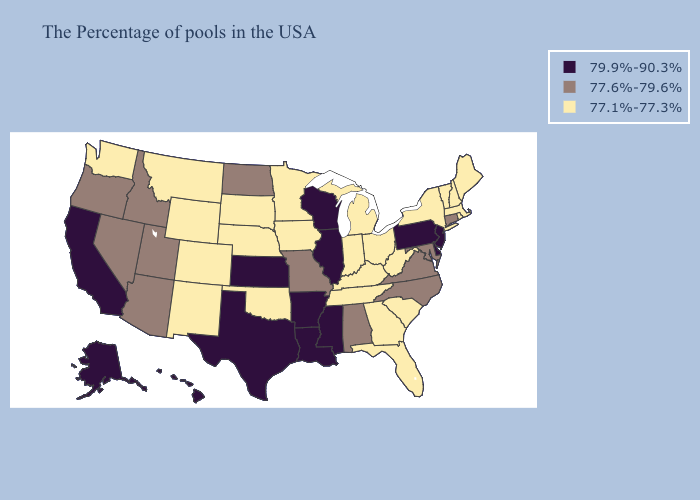Does Florida have the lowest value in the South?
Short answer required. Yes. Name the states that have a value in the range 77.6%-79.6%?
Give a very brief answer. Connecticut, Maryland, Virginia, North Carolina, Alabama, Missouri, North Dakota, Utah, Arizona, Idaho, Nevada, Oregon. What is the value of South Dakota?
Short answer required. 77.1%-77.3%. Name the states that have a value in the range 77.1%-77.3%?
Keep it brief. Maine, Massachusetts, Rhode Island, New Hampshire, Vermont, New York, South Carolina, West Virginia, Ohio, Florida, Georgia, Michigan, Kentucky, Indiana, Tennessee, Minnesota, Iowa, Nebraska, Oklahoma, South Dakota, Wyoming, Colorado, New Mexico, Montana, Washington. What is the value of Mississippi?
Give a very brief answer. 79.9%-90.3%. Name the states that have a value in the range 77.1%-77.3%?
Be succinct. Maine, Massachusetts, Rhode Island, New Hampshire, Vermont, New York, South Carolina, West Virginia, Ohio, Florida, Georgia, Michigan, Kentucky, Indiana, Tennessee, Minnesota, Iowa, Nebraska, Oklahoma, South Dakota, Wyoming, Colorado, New Mexico, Montana, Washington. Does the first symbol in the legend represent the smallest category?
Write a very short answer. No. Does the map have missing data?
Write a very short answer. No. What is the lowest value in states that border California?
Keep it brief. 77.6%-79.6%. Name the states that have a value in the range 77.1%-77.3%?
Short answer required. Maine, Massachusetts, Rhode Island, New Hampshire, Vermont, New York, South Carolina, West Virginia, Ohio, Florida, Georgia, Michigan, Kentucky, Indiana, Tennessee, Minnesota, Iowa, Nebraska, Oklahoma, South Dakota, Wyoming, Colorado, New Mexico, Montana, Washington. Among the states that border South Carolina , which have the lowest value?
Concise answer only. Georgia. Name the states that have a value in the range 77.1%-77.3%?
Give a very brief answer. Maine, Massachusetts, Rhode Island, New Hampshire, Vermont, New York, South Carolina, West Virginia, Ohio, Florida, Georgia, Michigan, Kentucky, Indiana, Tennessee, Minnesota, Iowa, Nebraska, Oklahoma, South Dakota, Wyoming, Colorado, New Mexico, Montana, Washington. Name the states that have a value in the range 79.9%-90.3%?
Be succinct. New Jersey, Delaware, Pennsylvania, Wisconsin, Illinois, Mississippi, Louisiana, Arkansas, Kansas, Texas, California, Alaska, Hawaii. What is the lowest value in the Northeast?
Quick response, please. 77.1%-77.3%. What is the value of Maryland?
Keep it brief. 77.6%-79.6%. 